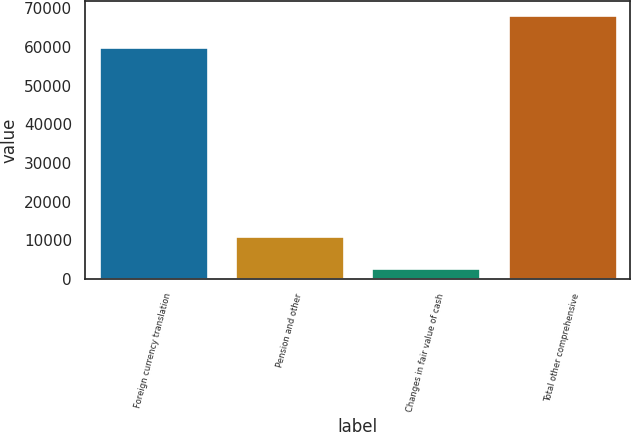<chart> <loc_0><loc_0><loc_500><loc_500><bar_chart><fcel>Foreign currency translation<fcel>Pension and other<fcel>Changes in fair value of cash<fcel>Total other comprehensive<nl><fcel>59970<fcel>11138<fcel>2699<fcel>68409<nl></chart> 